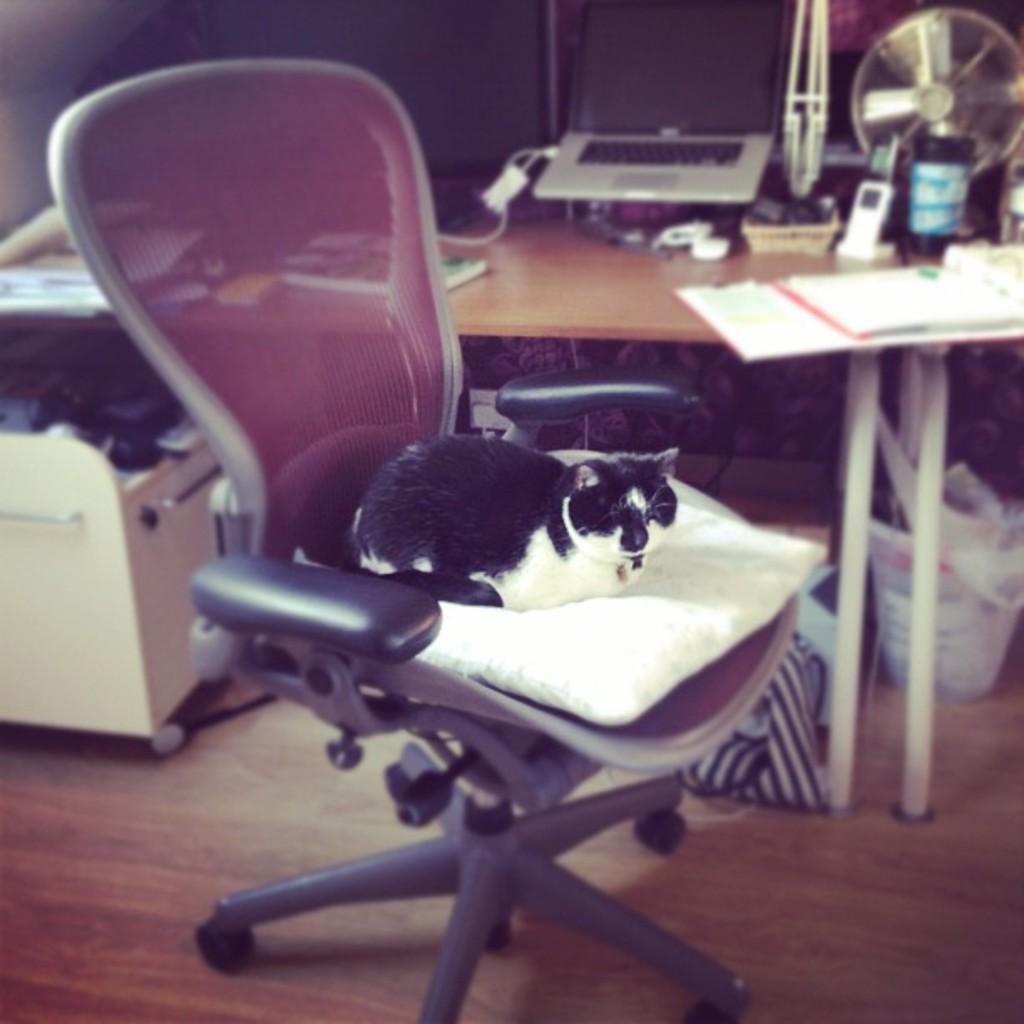Could you give a brief overview of what you see in this image? In this image there is a chair in the middle and a cat sitting on it. In the background there is a table. On the table there are some books, fan, jar, telephone , a laptop and some papers. In the left there is a desk. 